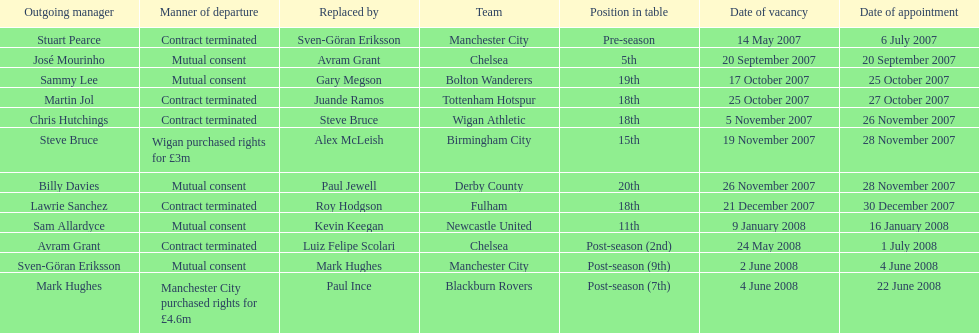What was the top team according to position in table called? Manchester City. 